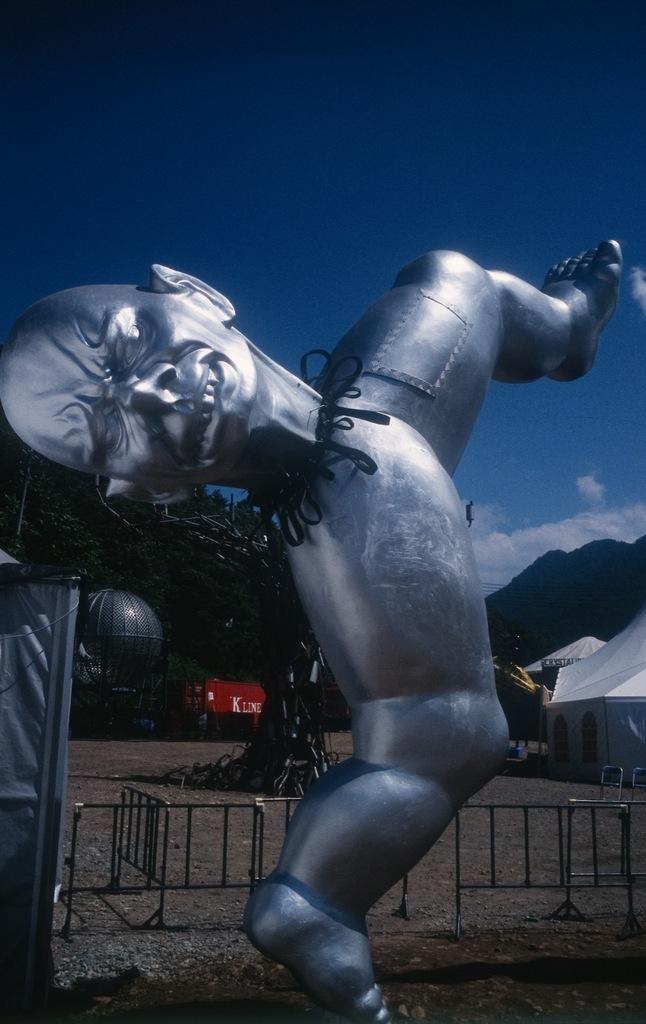How would you summarize this image in a sentence or two? In this picture there is a statue in the center of the image and there is a boundary behind it and there are tents and trees in the background area of the image. 